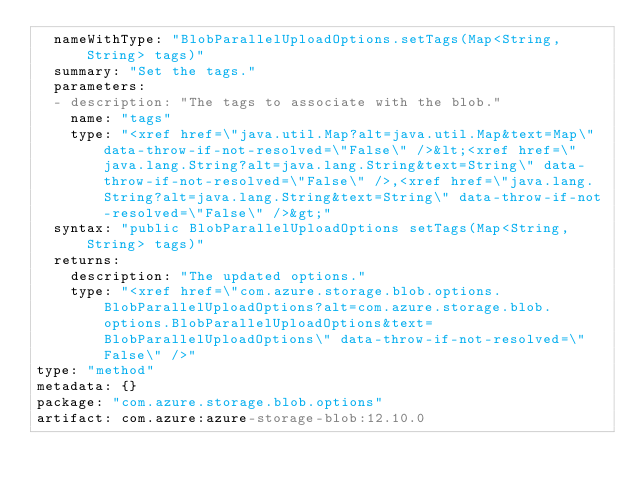Convert code to text. <code><loc_0><loc_0><loc_500><loc_500><_YAML_>  nameWithType: "BlobParallelUploadOptions.setTags(Map<String,String> tags)"
  summary: "Set the tags."
  parameters:
  - description: "The tags to associate with the blob."
    name: "tags"
    type: "<xref href=\"java.util.Map?alt=java.util.Map&text=Map\" data-throw-if-not-resolved=\"False\" />&lt;<xref href=\"java.lang.String?alt=java.lang.String&text=String\" data-throw-if-not-resolved=\"False\" />,<xref href=\"java.lang.String?alt=java.lang.String&text=String\" data-throw-if-not-resolved=\"False\" />&gt;"
  syntax: "public BlobParallelUploadOptions setTags(Map<String,String> tags)"
  returns:
    description: "The updated options."
    type: "<xref href=\"com.azure.storage.blob.options.BlobParallelUploadOptions?alt=com.azure.storage.blob.options.BlobParallelUploadOptions&text=BlobParallelUploadOptions\" data-throw-if-not-resolved=\"False\" />"
type: "method"
metadata: {}
package: "com.azure.storage.blob.options"
artifact: com.azure:azure-storage-blob:12.10.0
</code> 